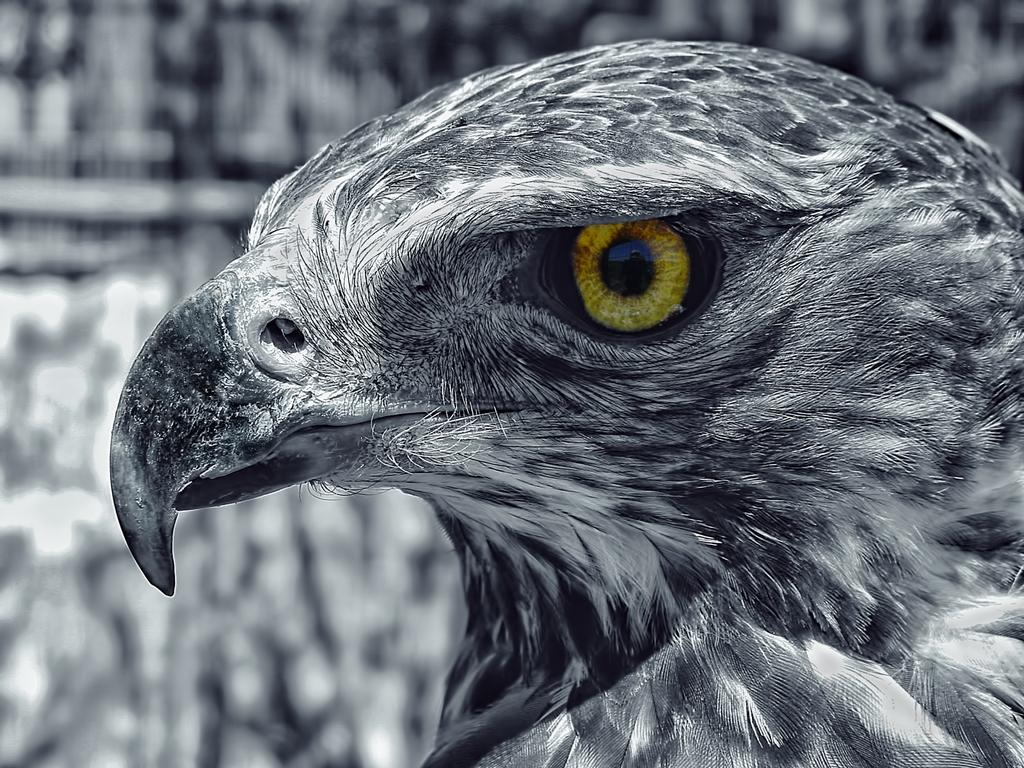What is the color scheme of the image? The image is black and white. What is the main subject of the image? There is a face of an eagle in the image. How would you describe the background of the image? The background of the image appears blurry. Can you see your friend in the image? There is no friend present in the image; it features the face of an eagle. What type of thing is floating in the sea in the image? There is no sea or floating thing present in the image. 